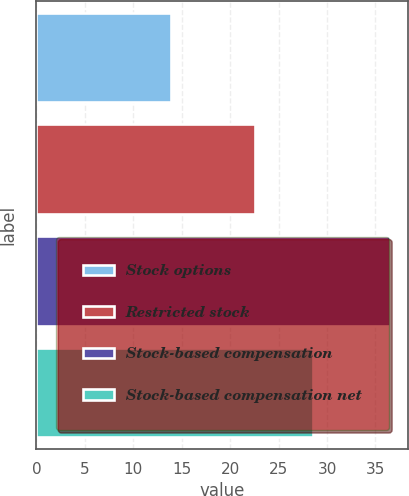<chart> <loc_0><loc_0><loc_500><loc_500><bar_chart><fcel>Stock options<fcel>Restricted stock<fcel>Stock-based compensation<fcel>Stock-based compensation net<nl><fcel>13.9<fcel>22.6<fcel>36.5<fcel>28.5<nl></chart> 